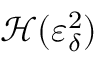<formula> <loc_0><loc_0><loc_500><loc_500>\mathcal { H } ( \varepsilon _ { \delta } ^ { 2 } )</formula> 